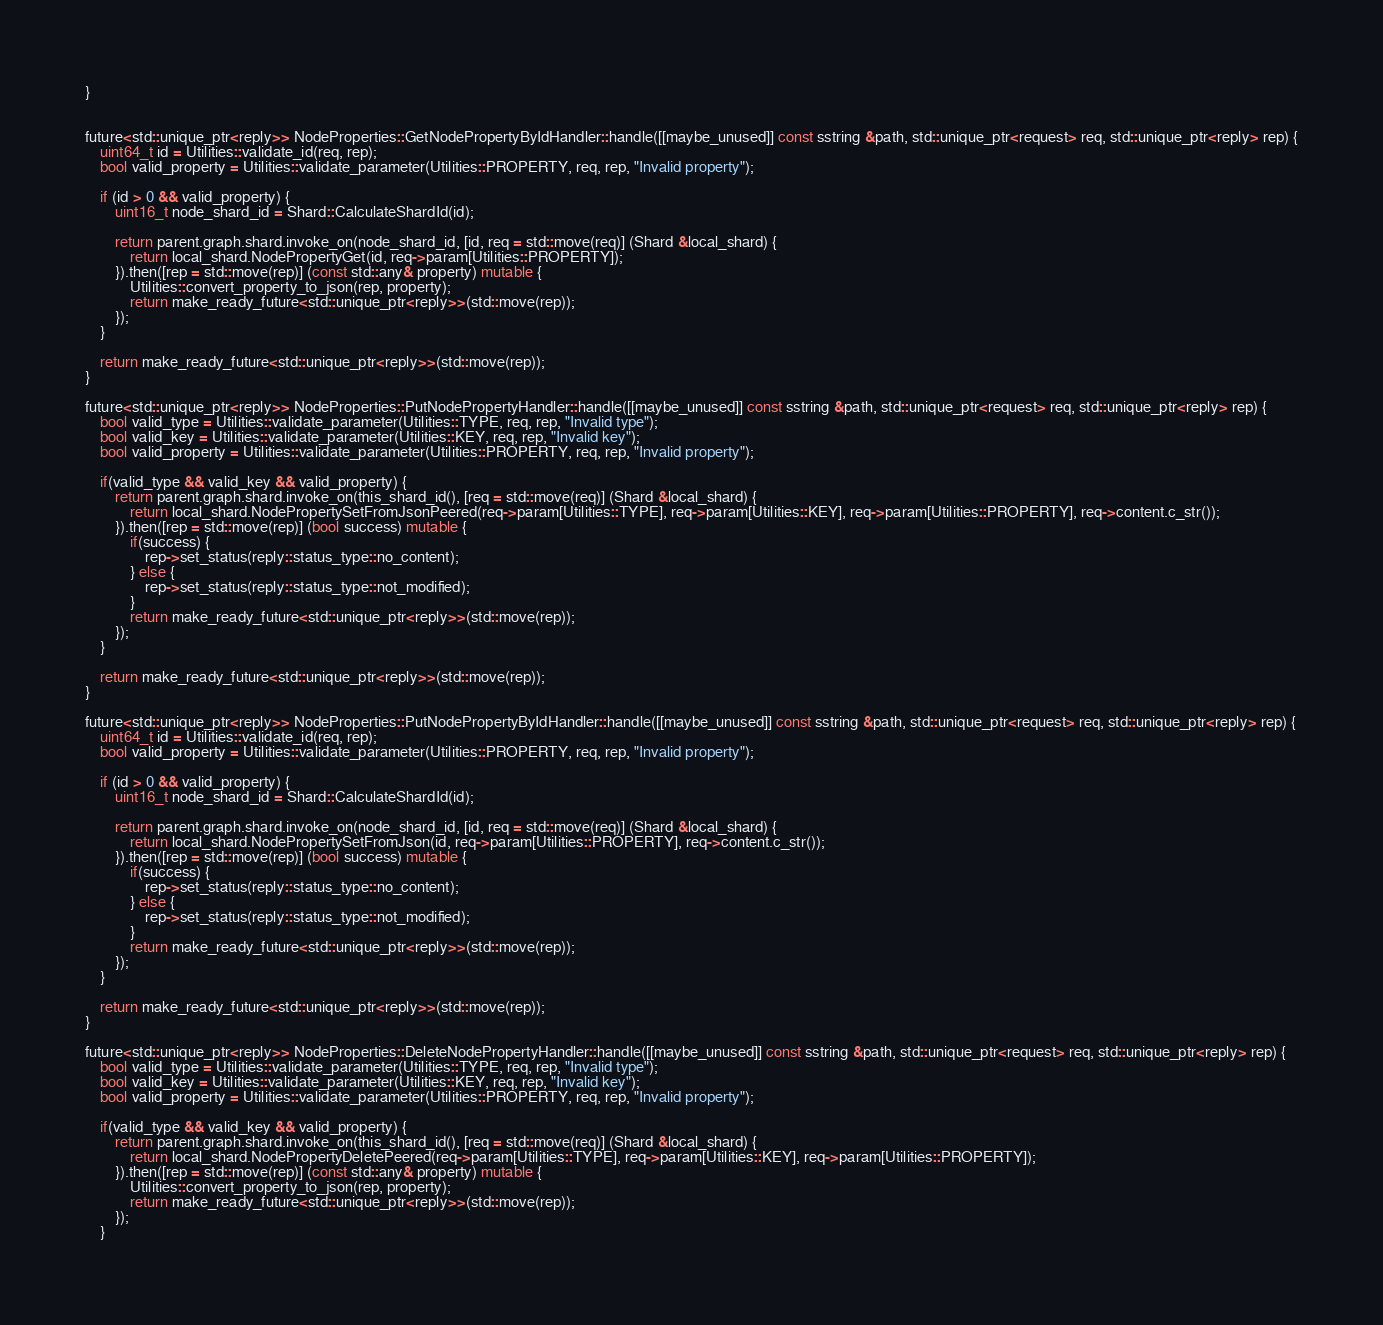Convert code to text. <code><loc_0><loc_0><loc_500><loc_500><_C++_>}


future<std::unique_ptr<reply>> NodeProperties::GetNodePropertyByIdHandler::handle([[maybe_unused]] const sstring &path, std::unique_ptr<request> req, std::unique_ptr<reply> rep) {
    uint64_t id = Utilities::validate_id(req, rep);
    bool valid_property = Utilities::validate_parameter(Utilities::PROPERTY, req, rep, "Invalid property");

    if (id > 0 && valid_property) {
        uint16_t node_shard_id = Shard::CalculateShardId(id);

        return parent.graph.shard.invoke_on(node_shard_id, [id, req = std::move(req)] (Shard &local_shard) {
            return local_shard.NodePropertyGet(id, req->param[Utilities::PROPERTY]);
        }).then([rep = std::move(rep)] (const std::any& property) mutable {
            Utilities::convert_property_to_json(rep, property);
            return make_ready_future<std::unique_ptr<reply>>(std::move(rep));
        });
    }

    return make_ready_future<std::unique_ptr<reply>>(std::move(rep));
}

future<std::unique_ptr<reply>> NodeProperties::PutNodePropertyHandler::handle([[maybe_unused]] const sstring &path, std::unique_ptr<request> req, std::unique_ptr<reply> rep) {
    bool valid_type = Utilities::validate_parameter(Utilities::TYPE, req, rep, "Invalid type");
    bool valid_key = Utilities::validate_parameter(Utilities::KEY, req, rep, "Invalid key");
    bool valid_property = Utilities::validate_parameter(Utilities::PROPERTY, req, rep, "Invalid property");

    if(valid_type && valid_key && valid_property) {
        return parent.graph.shard.invoke_on(this_shard_id(), [req = std::move(req)] (Shard &local_shard) {
            return local_shard.NodePropertySetFromJsonPeered(req->param[Utilities::TYPE], req->param[Utilities::KEY], req->param[Utilities::PROPERTY], req->content.c_str());
        }).then([rep = std::move(rep)] (bool success) mutable {
            if(success) {
                rep->set_status(reply::status_type::no_content);
            } else {
                rep->set_status(reply::status_type::not_modified);
            }
            return make_ready_future<std::unique_ptr<reply>>(std::move(rep));
        });
    }

    return make_ready_future<std::unique_ptr<reply>>(std::move(rep));
}

future<std::unique_ptr<reply>> NodeProperties::PutNodePropertyByIdHandler::handle([[maybe_unused]] const sstring &path, std::unique_ptr<request> req, std::unique_ptr<reply> rep) {
    uint64_t id = Utilities::validate_id(req, rep);
    bool valid_property = Utilities::validate_parameter(Utilities::PROPERTY, req, rep, "Invalid property");

    if (id > 0 && valid_property) {
        uint16_t node_shard_id = Shard::CalculateShardId(id);

        return parent.graph.shard.invoke_on(node_shard_id, [id, req = std::move(req)] (Shard &local_shard) {
            return local_shard.NodePropertySetFromJson(id, req->param[Utilities::PROPERTY], req->content.c_str());
        }).then([rep = std::move(rep)] (bool success) mutable {
            if(success) {
                rep->set_status(reply::status_type::no_content);
            } else {
                rep->set_status(reply::status_type::not_modified);
            }
            return make_ready_future<std::unique_ptr<reply>>(std::move(rep));
        });
    }

    return make_ready_future<std::unique_ptr<reply>>(std::move(rep));
}

future<std::unique_ptr<reply>> NodeProperties::DeleteNodePropertyHandler::handle([[maybe_unused]] const sstring &path, std::unique_ptr<request> req, std::unique_ptr<reply> rep) {
    bool valid_type = Utilities::validate_parameter(Utilities::TYPE, req, rep, "Invalid type");
    bool valid_key = Utilities::validate_parameter(Utilities::KEY, req, rep, "Invalid key");
    bool valid_property = Utilities::validate_parameter(Utilities::PROPERTY, req, rep, "Invalid property");

    if(valid_type && valid_key && valid_property) {
        return parent.graph.shard.invoke_on(this_shard_id(), [req = std::move(req)] (Shard &local_shard) {
            return local_shard.NodePropertyDeletePeered(req->param[Utilities::TYPE], req->param[Utilities::KEY], req->param[Utilities::PROPERTY]);
        }).then([rep = std::move(rep)] (const std::any& property) mutable {
            Utilities::convert_property_to_json(rep, property);
            return make_ready_future<std::unique_ptr<reply>>(std::move(rep));
        });
    }
</code> 